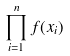Convert formula to latex. <formula><loc_0><loc_0><loc_500><loc_500>\prod _ { i = 1 } ^ { n } f ( x _ { i } )</formula> 